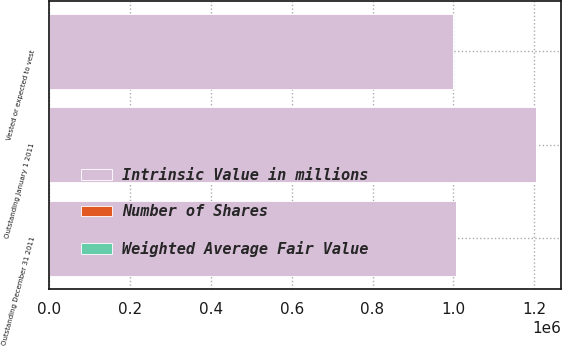<chart> <loc_0><loc_0><loc_500><loc_500><stacked_bar_chart><ecel><fcel>Outstanding January 1 2011<fcel>Outstanding December 31 2011<fcel>Vested or expected to vest<nl><fcel>Intrinsic Value in millions<fcel>1.20512e+06<fcel>1.00576e+06<fcel>998106<nl><fcel>Number of Shares<fcel>44.03<fcel>46.98<fcel>46.79<nl><fcel>Weighted Average Fair Value<fcel>101<fcel>84<fcel>83<nl></chart> 